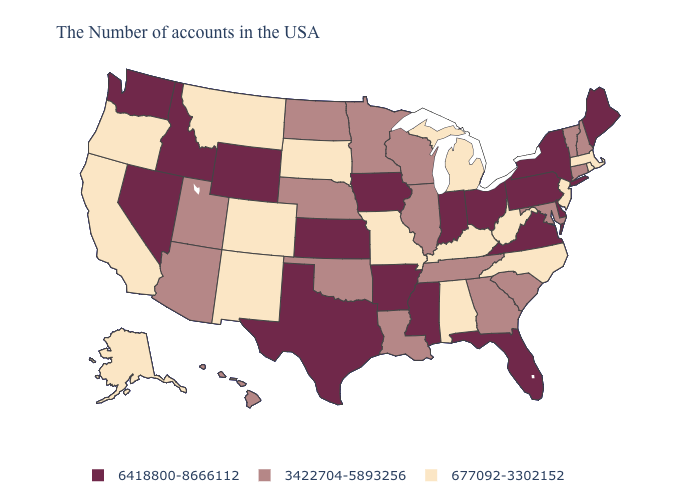How many symbols are there in the legend?
Quick response, please. 3. Which states have the lowest value in the USA?
Give a very brief answer. Massachusetts, Rhode Island, New Jersey, North Carolina, West Virginia, Michigan, Kentucky, Alabama, Missouri, South Dakota, Colorado, New Mexico, Montana, California, Oregon, Alaska. Among the states that border Oklahoma , which have the lowest value?
Write a very short answer. Missouri, Colorado, New Mexico. What is the lowest value in the USA?
Quick response, please. 677092-3302152. Does Kansas have the highest value in the MidWest?
Concise answer only. Yes. What is the highest value in the West ?
Answer briefly. 6418800-8666112. Which states hav the highest value in the South?
Write a very short answer. Delaware, Virginia, Florida, Mississippi, Arkansas, Texas. Among the states that border Nevada , which have the lowest value?
Short answer required. California, Oregon. Which states have the lowest value in the USA?
Keep it brief. Massachusetts, Rhode Island, New Jersey, North Carolina, West Virginia, Michigan, Kentucky, Alabama, Missouri, South Dakota, Colorado, New Mexico, Montana, California, Oregon, Alaska. Does Arkansas have the lowest value in the South?
Be succinct. No. Which states hav the highest value in the South?
Keep it brief. Delaware, Virginia, Florida, Mississippi, Arkansas, Texas. What is the lowest value in states that border Colorado?
Answer briefly. 677092-3302152. Name the states that have a value in the range 3422704-5893256?
Be succinct. New Hampshire, Vermont, Connecticut, Maryland, South Carolina, Georgia, Tennessee, Wisconsin, Illinois, Louisiana, Minnesota, Nebraska, Oklahoma, North Dakota, Utah, Arizona, Hawaii. What is the value of New Jersey?
Keep it brief. 677092-3302152. Name the states that have a value in the range 677092-3302152?
Answer briefly. Massachusetts, Rhode Island, New Jersey, North Carolina, West Virginia, Michigan, Kentucky, Alabama, Missouri, South Dakota, Colorado, New Mexico, Montana, California, Oregon, Alaska. 